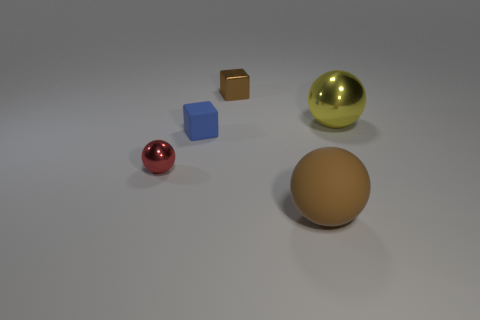How does the lighting in the scene affect the appearance of the objects? The lighting in the scene is soft and diffuse, casting gentle shadows and subtly highlighting the contours of the objects. It enhances the glossiness of the reflective surfaces, making the metallic spheres and the reflective cube stand out, while the matte surfaces, like the small cube and the larger sphere, absorb the light, giving them a subdued appearance. 